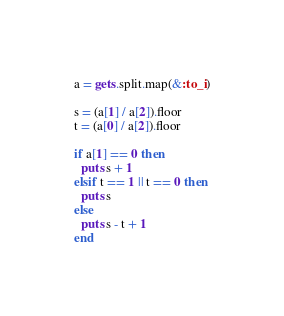<code> <loc_0><loc_0><loc_500><loc_500><_Ruby_>a = gets.split.map(&:to_i)

s = (a[1] / a[2]).floor
t = (a[0] / a[2]).floor

if a[1] == 0 then
  puts s + 1
elsif t == 1 || t == 0 then
  puts s
else
  puts s - t + 1
end

</code> 